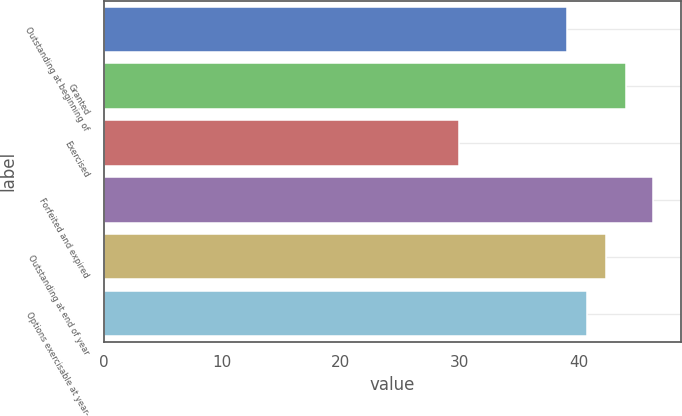<chart> <loc_0><loc_0><loc_500><loc_500><bar_chart><fcel>Outstanding at beginning of<fcel>Granted<fcel>Exercised<fcel>Forfeited and expired<fcel>Outstanding at end of year<fcel>Options exercisable at year-<nl><fcel>39.08<fcel>44<fcel>29.93<fcel>46.3<fcel>42.36<fcel>40.72<nl></chart> 